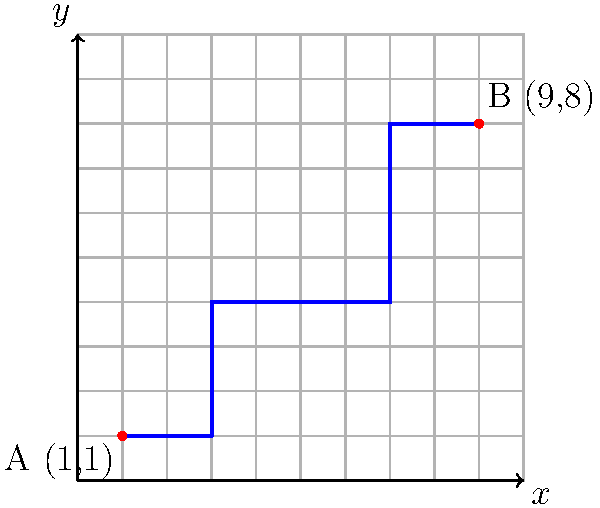As part of a new cycling initiative in Metro Manila, you're tasked with analyzing a popular bicycle route. The route starts at point A(1,1) and ends at point B(9,8) on the city grid, as shown in the diagram. If a cyclist maintains a constant speed of 15 km/h, how long will it take them to complete this route to the nearest minute? To solve this problem, we'll follow these steps:

1) First, we need to calculate the total distance of the route. We can do this by breaking down the route into segments and summing their lengths.

2) The route consists of 5 segments:
   (1,1) to (3,1)
   (3,1) to (3,4)
   (3,4) to (7,4)
   (7,4) to (7,8)
   (7,8) to (9,8)

3) Let's calculate the length of each segment:
   Segment 1: 3 - 1 = 2 units
   Segment 2: 4 - 1 = 3 units
   Segment 3: 7 - 3 = 4 units
   Segment 4: 8 - 4 = 4 units
   Segment 5: 9 - 7 = 2 units

4) Total distance = 2 + 3 + 4 + 4 + 2 = 15 units

5) Now, we need to convert this to kilometers. Let's assume each unit on our grid represents 1 km.
   So, the total distance is 15 km.

6) Given the cyclist's speed is 15 km/h, we can calculate the time using the formula:
   $Time = \frac{Distance}{Speed}$

7) $Time = \frac{15 \text{ km}}{15 \text{ km/h}} = 1 \text{ hour}$

8) Converting 1 hour to minutes: 1 * 60 = 60 minutes

Therefore, it will take the cyclist 60 minutes to complete the route.
Answer: 60 minutes 